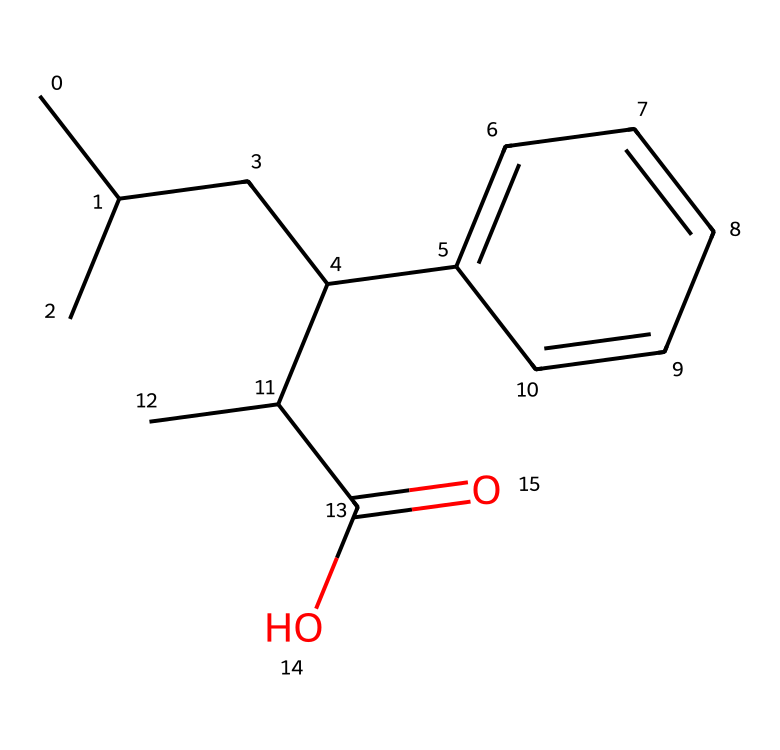What is the molecular formula of this chemical? By analyzing the structure represented in the SMILES notation, we can count the number of carbon (C), hydrogen (H), and oxygen (O) atoms. The structure contains 13 carbon atoms, 18 hydrogen atoms, and 2 oxygen atoms, resulting in the molecular formula C13H18O2.
Answer: C13H18O2 How many rings are present in this molecule? The SMILES shows a structure with a benzene ring indicated by the notation C1=CC=CC=C1. This denotes a single six-membered aromatic ring. Counting reveals 1 ring in the molecule.
Answer: 1 What functional group is present in this structure? The presence of the -C(O)OH group in the molecular structure indicates that this compound has a carboxylic acid functional group. This can be inferred from the Carboxylic acid notation given in the SMILES.
Answer: carboxylic acid Does this molecule have any chiral centers? To determine chirality, we examine the carbon atoms. A carbon atom is chiral if it has four different groups attached to it. In this structure, the carbon attached to the hydroxyl group (C(O)) is connected to a hydrogen atom, a carboxyl group, a propyl group, and a phenyl group. Thus, it is chiral.
Answer: Yes What type of drug is ibuprofen classified as? Ibuprofen is classified as a nonsteroidal anti-inflammatory drug (NSAID). This classification is based on its mechanism of action, primarily involving the inhibition of cyclooxygenase enzymes.
Answer: NSAID What is the primary action mechanism of ibuprofen in reducing inflammation? Ibuprofen primarily works by inhibiting the cyclooxygenase (COX) enzymes, which are responsible for converting arachidonic acid into prostaglandins, compounds that mediate inflammation. By blocking these enzymes, ibuprofen reduces the production of inflammatory mediators.
Answer: COX inhibition 